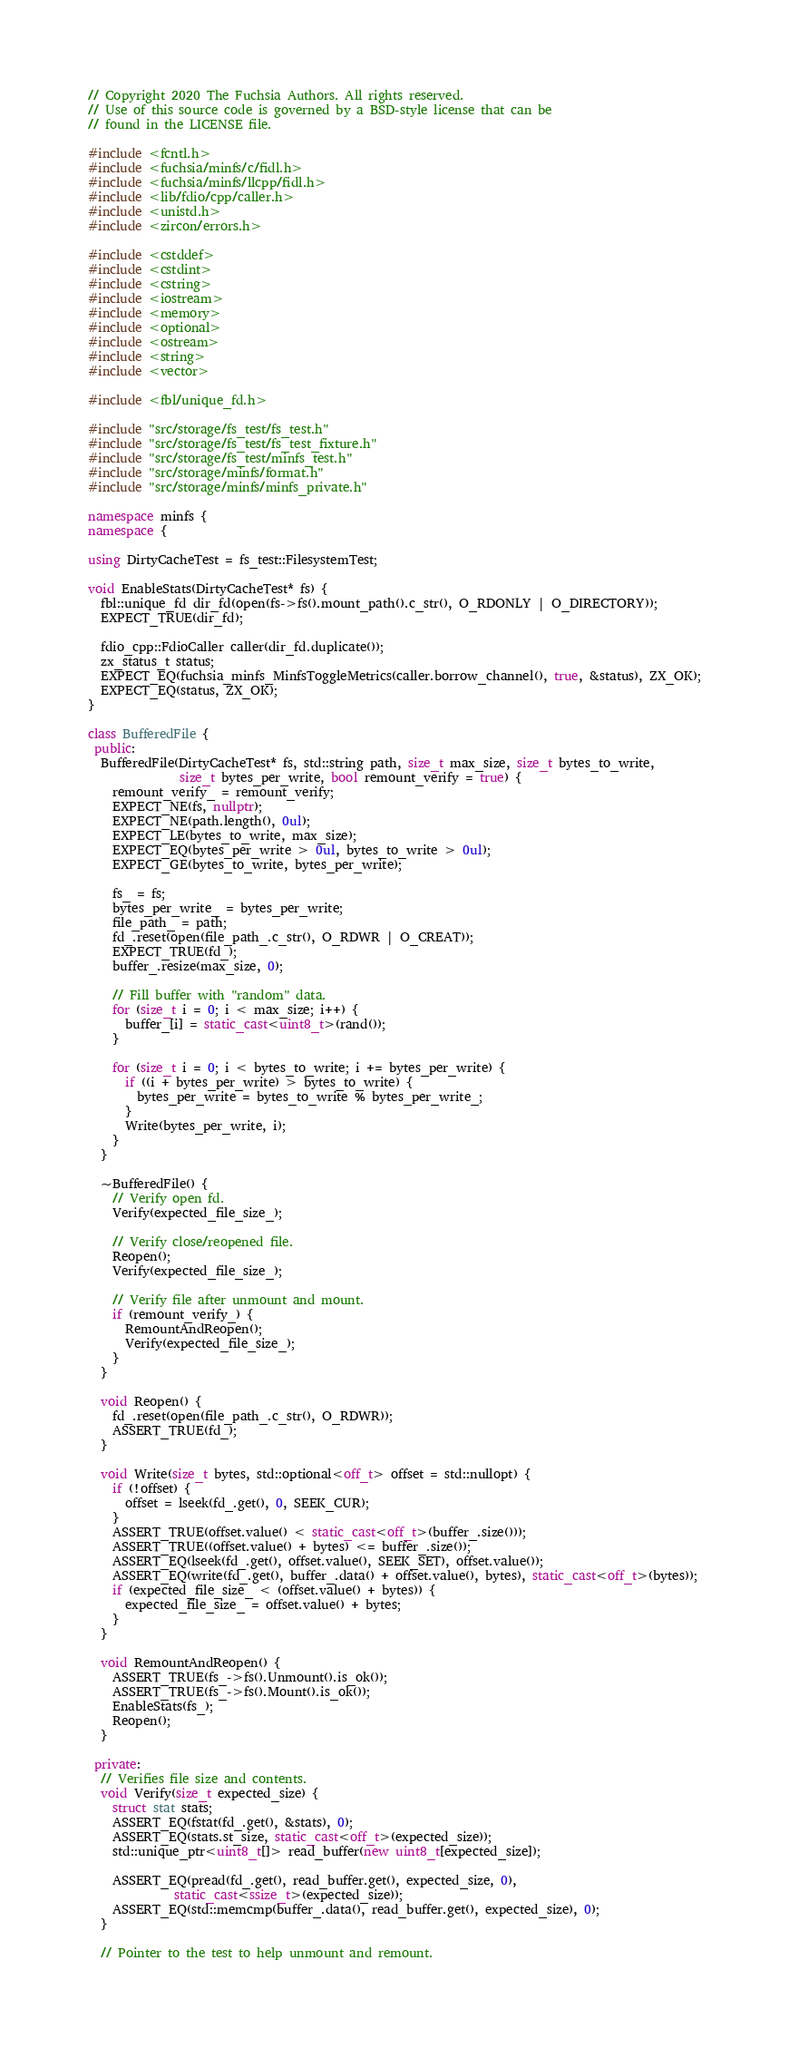Convert code to text. <code><loc_0><loc_0><loc_500><loc_500><_C++_>// Copyright 2020 The Fuchsia Authors. All rights reserved.
// Use of this source code is governed by a BSD-style license that can be
// found in the LICENSE file.

#include <fcntl.h>
#include <fuchsia/minfs/c/fidl.h>
#include <fuchsia/minfs/llcpp/fidl.h>
#include <lib/fdio/cpp/caller.h>
#include <unistd.h>
#include <zircon/errors.h>

#include <cstddef>
#include <cstdint>
#include <cstring>
#include <iostream>
#include <memory>
#include <optional>
#include <ostream>
#include <string>
#include <vector>

#include <fbl/unique_fd.h>

#include "src/storage/fs_test/fs_test.h"
#include "src/storage/fs_test/fs_test_fixture.h"
#include "src/storage/fs_test/minfs_test.h"
#include "src/storage/minfs/format.h"
#include "src/storage/minfs/minfs_private.h"

namespace minfs {
namespace {

using DirtyCacheTest = fs_test::FilesystemTest;

void EnableStats(DirtyCacheTest* fs) {
  fbl::unique_fd dir_fd(open(fs->fs().mount_path().c_str(), O_RDONLY | O_DIRECTORY));
  EXPECT_TRUE(dir_fd);

  fdio_cpp::FdioCaller caller(dir_fd.duplicate());
  zx_status_t status;
  EXPECT_EQ(fuchsia_minfs_MinfsToggleMetrics(caller.borrow_channel(), true, &status), ZX_OK);
  EXPECT_EQ(status, ZX_OK);
}

class BufferedFile {
 public:
  BufferedFile(DirtyCacheTest* fs, std::string path, size_t max_size, size_t bytes_to_write,
               size_t bytes_per_write, bool remount_verify = true) {
    remount_verify_ = remount_verify;
    EXPECT_NE(fs, nullptr);
    EXPECT_NE(path.length(), 0ul);
    EXPECT_LE(bytes_to_write, max_size);
    EXPECT_EQ(bytes_per_write > 0ul, bytes_to_write > 0ul);
    EXPECT_GE(bytes_to_write, bytes_per_write);

    fs_ = fs;
    bytes_per_write_ = bytes_per_write;
    file_path_ = path;
    fd_.reset(open(file_path_.c_str(), O_RDWR | O_CREAT));
    EXPECT_TRUE(fd_);
    buffer_.resize(max_size, 0);

    // Fill buffer with "random" data.
    for (size_t i = 0; i < max_size; i++) {
      buffer_[i] = static_cast<uint8_t>(rand());
    }

    for (size_t i = 0; i < bytes_to_write; i += bytes_per_write) {
      if ((i + bytes_per_write) > bytes_to_write) {
        bytes_per_write = bytes_to_write % bytes_per_write_;
      }
      Write(bytes_per_write, i);
    }
  }

  ~BufferedFile() {
    // Verify open fd.
    Verify(expected_file_size_);

    // Verify close/reopened file.
    Reopen();
    Verify(expected_file_size_);

    // Verify file after unmount and mount.
    if (remount_verify_) {
      RemountAndReopen();
      Verify(expected_file_size_);
    }
  }

  void Reopen() {
    fd_.reset(open(file_path_.c_str(), O_RDWR));
    ASSERT_TRUE(fd_);
  }

  void Write(size_t bytes, std::optional<off_t> offset = std::nullopt) {
    if (!offset) {
      offset = lseek(fd_.get(), 0, SEEK_CUR);
    }
    ASSERT_TRUE(offset.value() < static_cast<off_t>(buffer_.size()));
    ASSERT_TRUE((offset.value() + bytes) <= buffer_.size());
    ASSERT_EQ(lseek(fd_.get(), offset.value(), SEEK_SET), offset.value());
    ASSERT_EQ(write(fd_.get(), buffer_.data() + offset.value(), bytes), static_cast<off_t>(bytes));
    if (expected_file_size_ < (offset.value() + bytes)) {
      expected_file_size_ = offset.value() + bytes;
    }
  }

  void RemountAndReopen() {
    ASSERT_TRUE(fs_->fs().Unmount().is_ok());
    ASSERT_TRUE(fs_->fs().Mount().is_ok());
    EnableStats(fs_);
    Reopen();
  }

 private:
  // Verifies file size and contents.
  void Verify(size_t expected_size) {
    struct stat stats;
    ASSERT_EQ(fstat(fd_.get(), &stats), 0);
    ASSERT_EQ(stats.st_size, static_cast<off_t>(expected_size));
    std::unique_ptr<uint8_t[]> read_buffer(new uint8_t[expected_size]);

    ASSERT_EQ(pread(fd_.get(), read_buffer.get(), expected_size, 0),
              static_cast<ssize_t>(expected_size));
    ASSERT_EQ(std::memcmp(buffer_.data(), read_buffer.get(), expected_size), 0);
  }

  // Pointer to the test to help unmount and remount.</code> 